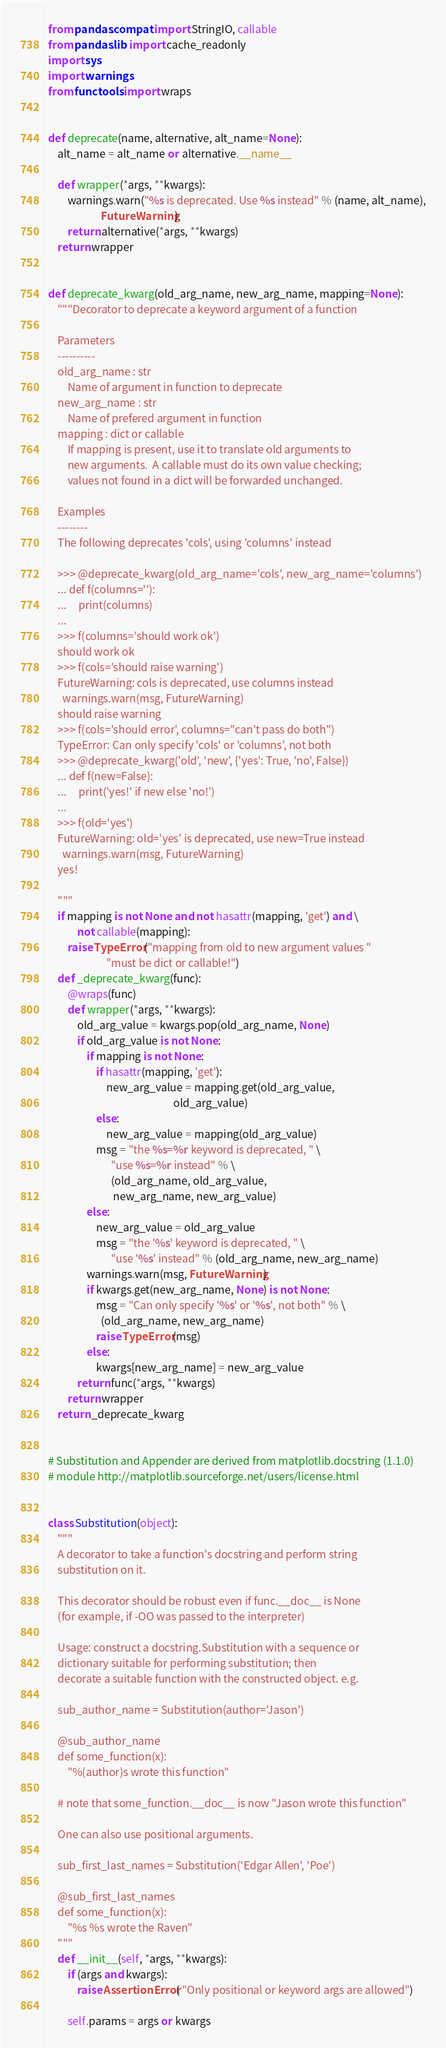Convert code to text. <code><loc_0><loc_0><loc_500><loc_500><_Python_>from pandas.compat import StringIO, callable
from pandas.lib import cache_readonly
import sys
import warnings
from functools import wraps


def deprecate(name, alternative, alt_name=None):
    alt_name = alt_name or alternative.__name__

    def wrapper(*args, **kwargs):
        warnings.warn("%s is deprecated. Use %s instead" % (name, alt_name),
                      FutureWarning)
        return alternative(*args, **kwargs)
    return wrapper


def deprecate_kwarg(old_arg_name, new_arg_name, mapping=None):
    """Decorator to deprecate a keyword argument of a function

    Parameters
    ----------
    old_arg_name : str
        Name of argument in function to deprecate
    new_arg_name : str
        Name of prefered argument in function
    mapping : dict or callable
        If mapping is present, use it to translate old arguments to
        new arguments.  A callable must do its own value checking;
        values not found in a dict will be forwarded unchanged.

    Examples
    --------
    The following deprecates 'cols', using 'columns' instead

    >>> @deprecate_kwarg(old_arg_name='cols', new_arg_name='columns')
    ... def f(columns=''):
    ...     print(columns)
    ...
    >>> f(columns='should work ok')
    should work ok
    >>> f(cols='should raise warning')
    FutureWarning: cols is deprecated, use columns instead
      warnings.warn(msg, FutureWarning)
    should raise warning
    >>> f(cols='should error', columns="can't pass do both")
    TypeError: Can only specify 'cols' or 'columns', not both
    >>> @deprecate_kwarg('old', 'new', {'yes': True, 'no', False})
    ... def f(new=False):
    ...     print('yes!' if new else 'no!')
    ...
    >>> f(old='yes')
    FutureWarning: old='yes' is deprecated, use new=True instead
      warnings.warn(msg, FutureWarning)
    yes!

    """
    if mapping is not None and not hasattr(mapping, 'get') and \
            not callable(mapping):
        raise TypeError("mapping from old to new argument values "
                        "must be dict or callable!")
    def _deprecate_kwarg(func):
        @wraps(func)
        def wrapper(*args, **kwargs):
            old_arg_value = kwargs.pop(old_arg_name, None)
            if old_arg_value is not None:
                if mapping is not None:
                    if hasattr(mapping, 'get'):
                        new_arg_value = mapping.get(old_arg_value,
                                                    old_arg_value)
                    else:
                        new_arg_value = mapping(old_arg_value)
                    msg = "the %s=%r keyword is deprecated, " \
                          "use %s=%r instead" % \
                          (old_arg_name, old_arg_value,
                           new_arg_name, new_arg_value)
                else:
                    new_arg_value = old_arg_value
                    msg = "the '%s' keyword is deprecated, " \
                          "use '%s' instead" % (old_arg_name, new_arg_name)
                warnings.warn(msg, FutureWarning)
                if kwargs.get(new_arg_name, None) is not None:
                    msg = "Can only specify '%s' or '%s', not both" % \
                      (old_arg_name, new_arg_name)
                    raise TypeError(msg)
                else:
                    kwargs[new_arg_name] = new_arg_value
            return func(*args, **kwargs)
        return wrapper
    return _deprecate_kwarg


# Substitution and Appender are derived from matplotlib.docstring (1.1.0)
# module http://matplotlib.sourceforge.net/users/license.html


class Substitution(object):
    """
    A decorator to take a function's docstring and perform string
    substitution on it.

    This decorator should be robust even if func.__doc__ is None
    (for example, if -OO was passed to the interpreter)

    Usage: construct a docstring.Substitution with a sequence or
    dictionary suitable for performing substitution; then
    decorate a suitable function with the constructed object. e.g.

    sub_author_name = Substitution(author='Jason')

    @sub_author_name
    def some_function(x):
        "%(author)s wrote this function"

    # note that some_function.__doc__ is now "Jason wrote this function"

    One can also use positional arguments.

    sub_first_last_names = Substitution('Edgar Allen', 'Poe')

    @sub_first_last_names
    def some_function(x):
        "%s %s wrote the Raven"
    """
    def __init__(self, *args, **kwargs):
        if (args and kwargs):
            raise AssertionError( "Only positional or keyword args are allowed")

        self.params = args or kwargs
</code> 